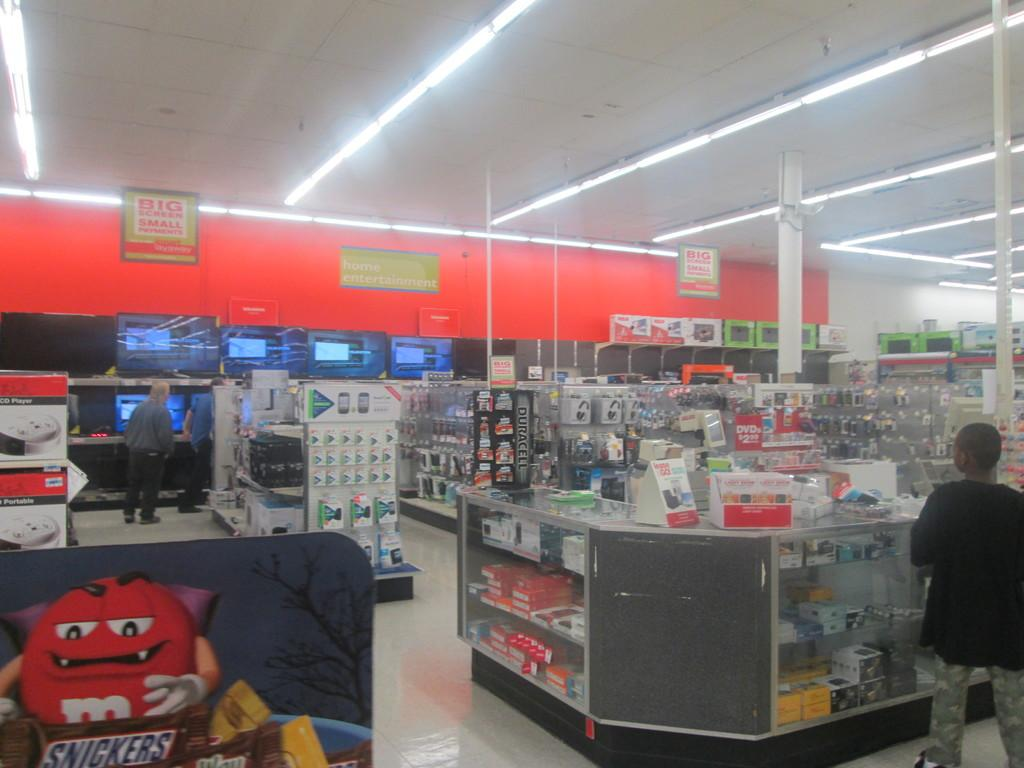<image>
Create a compact narrative representing the image presented. A store with a red M&M character holding a snickers bar.banner ad. 